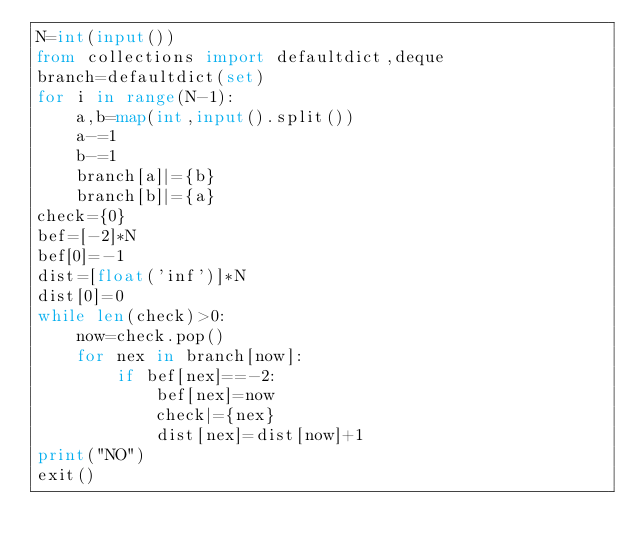<code> <loc_0><loc_0><loc_500><loc_500><_Python_>N=int(input())
from collections import defaultdict,deque
branch=defaultdict(set)
for i in range(N-1):
    a,b=map(int,input().split())
    a-=1
    b-=1
    branch[a]|={b}
    branch[b]|={a}
check={0}
bef=[-2]*N
bef[0]=-1
dist=[float('inf')]*N
dist[0]=0
while len(check)>0:
    now=check.pop()
    for nex in branch[now]:
        if bef[nex]==-2:
            bef[nex]=now
            check|={nex}
            dist[nex]=dist[now]+1
print("NO")
exit()</code> 